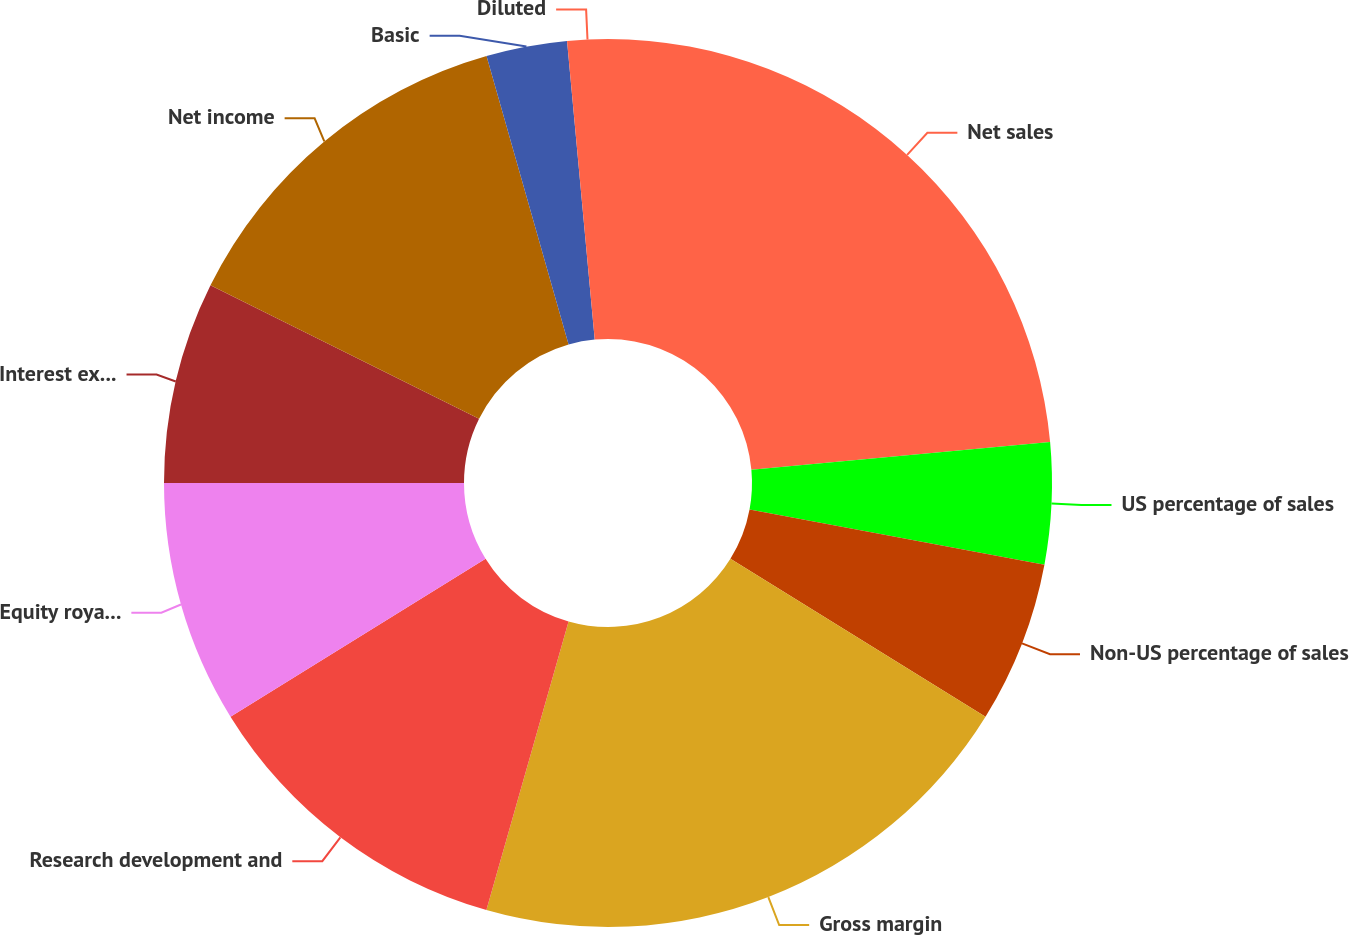Convert chart to OTSL. <chart><loc_0><loc_0><loc_500><loc_500><pie_chart><fcel>Net sales<fcel>US percentage of sales<fcel>Non-US percentage of sales<fcel>Gross margin<fcel>Research development and<fcel>Equity royalty and interest<fcel>Interest expense<fcel>Net income<fcel>Basic<fcel>Diluted<nl><fcel>23.53%<fcel>4.41%<fcel>5.88%<fcel>20.59%<fcel>11.76%<fcel>8.82%<fcel>7.35%<fcel>13.24%<fcel>2.94%<fcel>1.47%<nl></chart> 